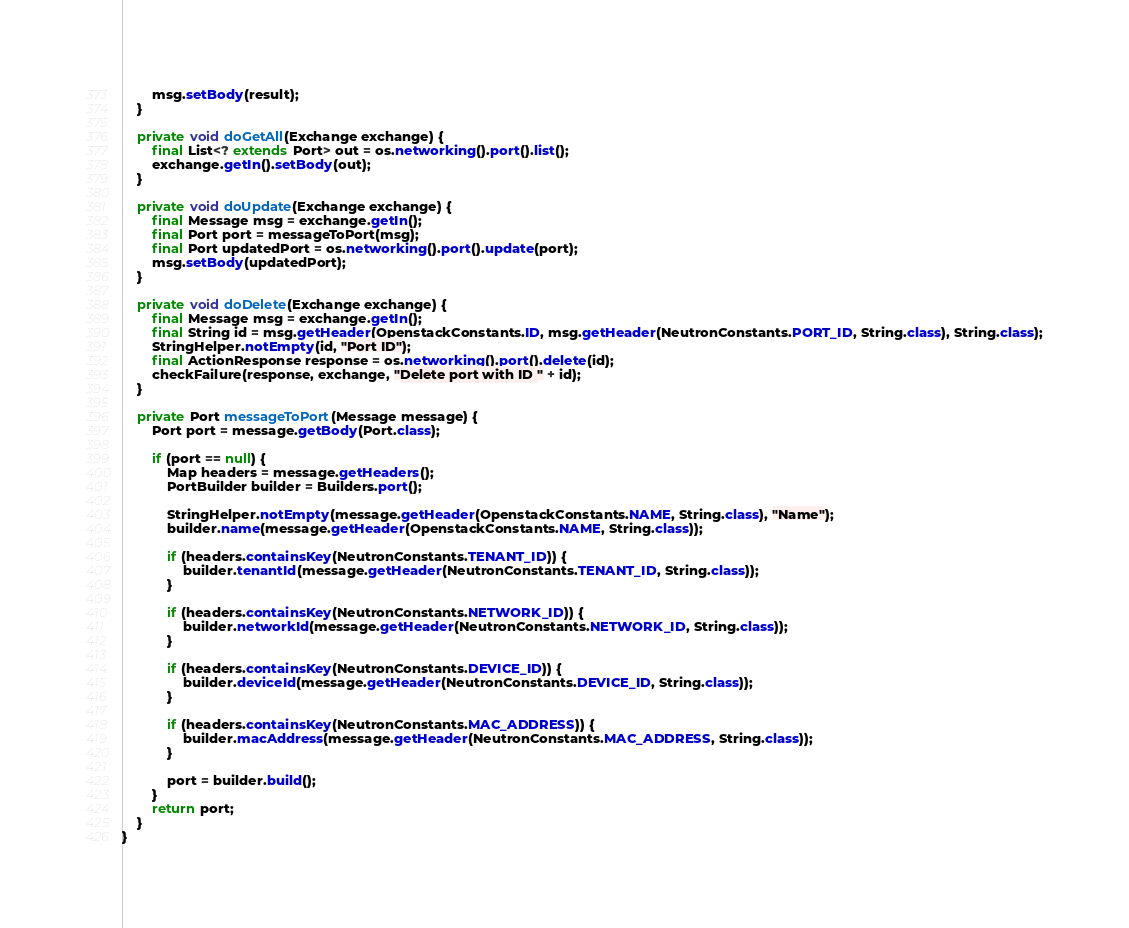Convert code to text. <code><loc_0><loc_0><loc_500><loc_500><_Java_>        msg.setBody(result);
    }

    private void doGetAll(Exchange exchange) {
        final List<? extends Port> out = os.networking().port().list();
        exchange.getIn().setBody(out);
    }

    private void doUpdate(Exchange exchange) {
        final Message msg = exchange.getIn();
        final Port port = messageToPort(msg);
        final Port updatedPort = os.networking().port().update(port);
        msg.setBody(updatedPort);
    }

    private void doDelete(Exchange exchange) {
        final Message msg = exchange.getIn();
        final String id = msg.getHeader(OpenstackConstants.ID, msg.getHeader(NeutronConstants.PORT_ID, String.class), String.class);
        StringHelper.notEmpty(id, "Port ID");
        final ActionResponse response = os.networking().port().delete(id);
        checkFailure(response, exchange, "Delete port with ID " + id);
    }

    private Port messageToPort(Message message) {
        Port port = message.getBody(Port.class);

        if (port == null) {
            Map headers = message.getHeaders();
            PortBuilder builder = Builders.port();

            StringHelper.notEmpty(message.getHeader(OpenstackConstants.NAME, String.class), "Name");
            builder.name(message.getHeader(OpenstackConstants.NAME, String.class));

            if (headers.containsKey(NeutronConstants.TENANT_ID)) {
                builder.tenantId(message.getHeader(NeutronConstants.TENANT_ID, String.class));
            }

            if (headers.containsKey(NeutronConstants.NETWORK_ID)) {
                builder.networkId(message.getHeader(NeutronConstants.NETWORK_ID, String.class));
            }

            if (headers.containsKey(NeutronConstants.DEVICE_ID)) {
                builder.deviceId(message.getHeader(NeutronConstants.DEVICE_ID, String.class));
            }

            if (headers.containsKey(NeutronConstants.MAC_ADDRESS)) {
                builder.macAddress(message.getHeader(NeutronConstants.MAC_ADDRESS, String.class));
            }

            port = builder.build();
        }
        return port;
    }
}
</code> 